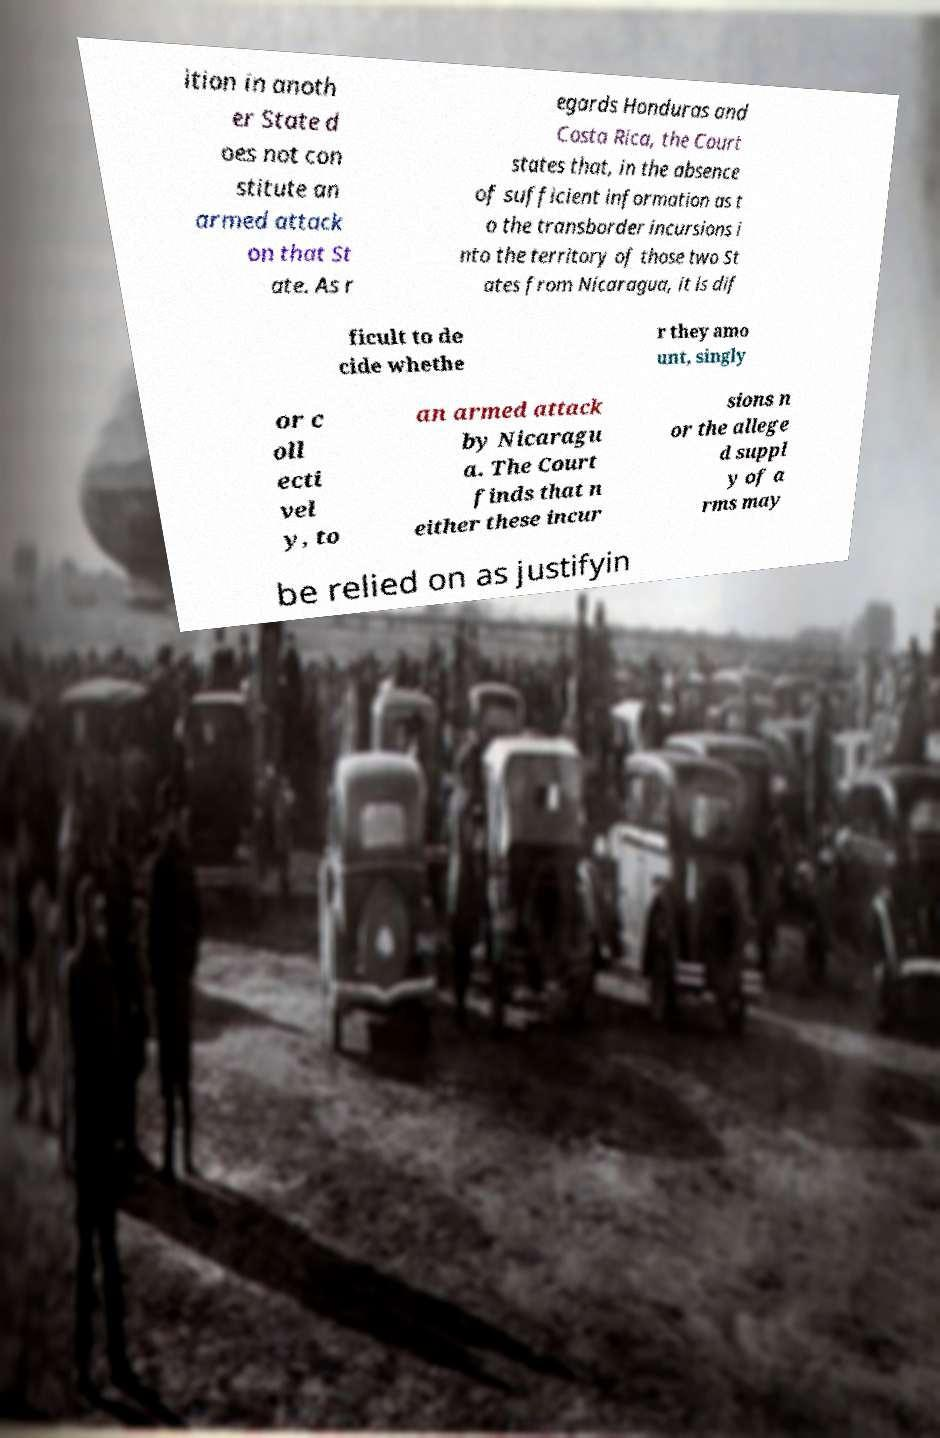Can you accurately transcribe the text from the provided image for me? ition in anoth er State d oes not con stitute an armed attack on that St ate. As r egards Honduras and Costa Rica, the Court states that, in the absence of sufficient information as t o the transborder incursions i nto the territory of those two St ates from Nicaragua, it is dif ficult to de cide whethe r they amo unt, singly or c oll ecti vel y, to an armed attack by Nicaragu a. The Court finds that n either these incur sions n or the allege d suppl y of a rms may be relied on as justifyin 